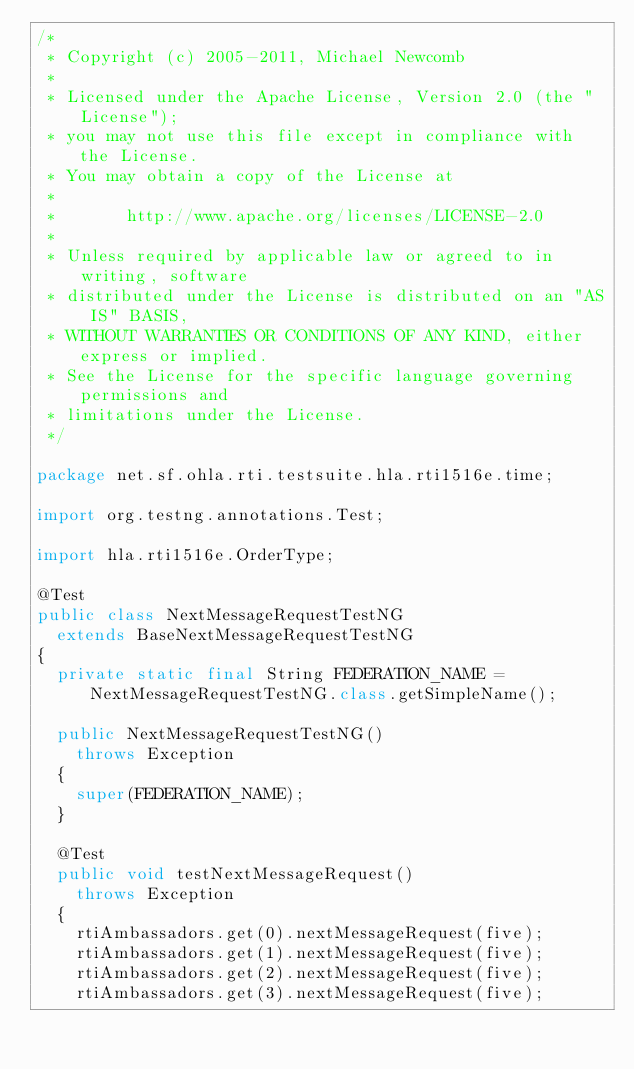<code> <loc_0><loc_0><loc_500><loc_500><_Java_>/*
 * Copyright (c) 2005-2011, Michael Newcomb
 *
 * Licensed under the Apache License, Version 2.0 (the "License");
 * you may not use this file except in compliance with the License.
 * You may obtain a copy of the License at
 *
 *       http://www.apache.org/licenses/LICENSE-2.0
 *
 * Unless required by applicable law or agreed to in writing, software
 * distributed under the License is distributed on an "AS IS" BASIS,
 * WITHOUT WARRANTIES OR CONDITIONS OF ANY KIND, either express or implied.
 * See the License for the specific language governing permissions and
 * limitations under the License.
 */

package net.sf.ohla.rti.testsuite.hla.rti1516e.time;

import org.testng.annotations.Test;

import hla.rti1516e.OrderType;

@Test
public class NextMessageRequestTestNG
  extends BaseNextMessageRequestTestNG
{
  private static final String FEDERATION_NAME = NextMessageRequestTestNG.class.getSimpleName();

  public NextMessageRequestTestNG()
    throws Exception
  {
    super(FEDERATION_NAME);
  }

  @Test
  public void testNextMessageRequest()
    throws Exception
  {
    rtiAmbassadors.get(0).nextMessageRequest(five);
    rtiAmbassadors.get(1).nextMessageRequest(five);
    rtiAmbassadors.get(2).nextMessageRequest(five);
    rtiAmbassadors.get(3).nextMessageRequest(five);</code> 